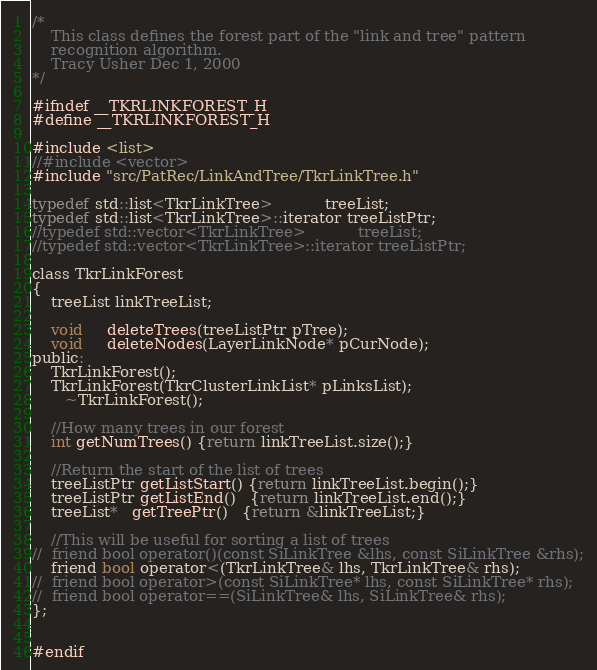<code> <loc_0><loc_0><loc_500><loc_500><_C_>/*
    This class defines the forest part of the "link and tree" pattern 
    recognition algorithm. 
    Tracy Usher Dec 1, 2000
*/

#ifndef __TKRLINKFOREST_H
#define __TKRLINKFOREST_H

#include <list>
//#include <vector>
#include "src/PatRec/LinkAndTree/TkrLinkTree.h"

typedef std::list<TkrLinkTree>           treeList;
typedef std::list<TkrLinkTree>::iterator treeListPtr;
//typedef std::vector<TkrLinkTree>           treeList;
//typedef std::vector<TkrLinkTree>::iterator treeListPtr;

class TkrLinkForest
{
    treeList linkTreeList;

    void     deleteTrees(treeListPtr pTree);
    void     deleteNodes(LayerLinkNode* pCurNode);
public:
    TkrLinkForest();
    TkrLinkForest(TkrClusterLinkList* pLinksList);
       ~TkrLinkForest();

    //How many trees in our forest
    int getNumTrees() {return linkTreeList.size();}

    //Return the start of the list of trees
    treeListPtr getListStart() {return linkTreeList.begin();}
    treeListPtr getListEnd()   {return linkTreeList.end();}
    treeList*   getTreePtr()   {return &linkTreeList;}

    //This will be useful for sorting a list of trees
//  friend bool operator()(const SiLinkTree &lhs, const SiLinkTree &rhs);
    friend bool operator<(TkrLinkTree& lhs, TkrLinkTree& rhs);
//  friend bool operator>(const SiLinkTree* lhs, const SiLinkTree* rhs);
//  friend bool operator==(SiLinkTree& lhs, SiLinkTree& rhs);
};


#endif
</code> 